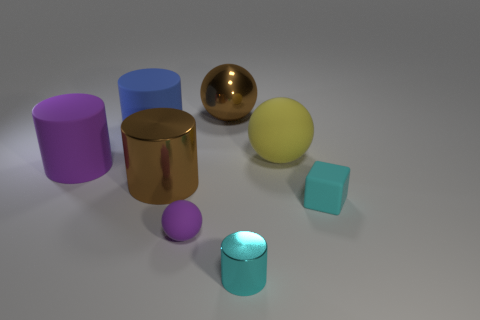Do the small cyan thing on the left side of the cyan block and the purple thing that is in front of the large purple thing have the same material?
Offer a terse response. No. There is another tiny rubber thing that is the same shape as the yellow matte object; what is its color?
Keep it short and to the point. Purple. The big ball in front of the big brown shiny object to the right of the small purple matte thing is made of what material?
Keep it short and to the point. Rubber. Is the shape of the big yellow matte object behind the large brown cylinder the same as the tiny cyan object right of the yellow ball?
Offer a very short reply. No. What is the size of the cylinder that is both to the right of the big blue rubber object and to the left of the large brown shiny sphere?
Ensure brevity in your answer.  Large. How many other objects are the same color as the big rubber ball?
Ensure brevity in your answer.  0. Is the large brown object in front of the big yellow object made of the same material as the yellow thing?
Give a very brief answer. No. Is there any other thing that has the same size as the shiny ball?
Keep it short and to the point. Yes. Is the number of tiny metallic cylinders left of the large purple object less than the number of brown balls that are behind the purple rubber ball?
Provide a short and direct response. Yes. Are there any other things that have the same shape as the tiny cyan rubber object?
Make the answer very short. No. 